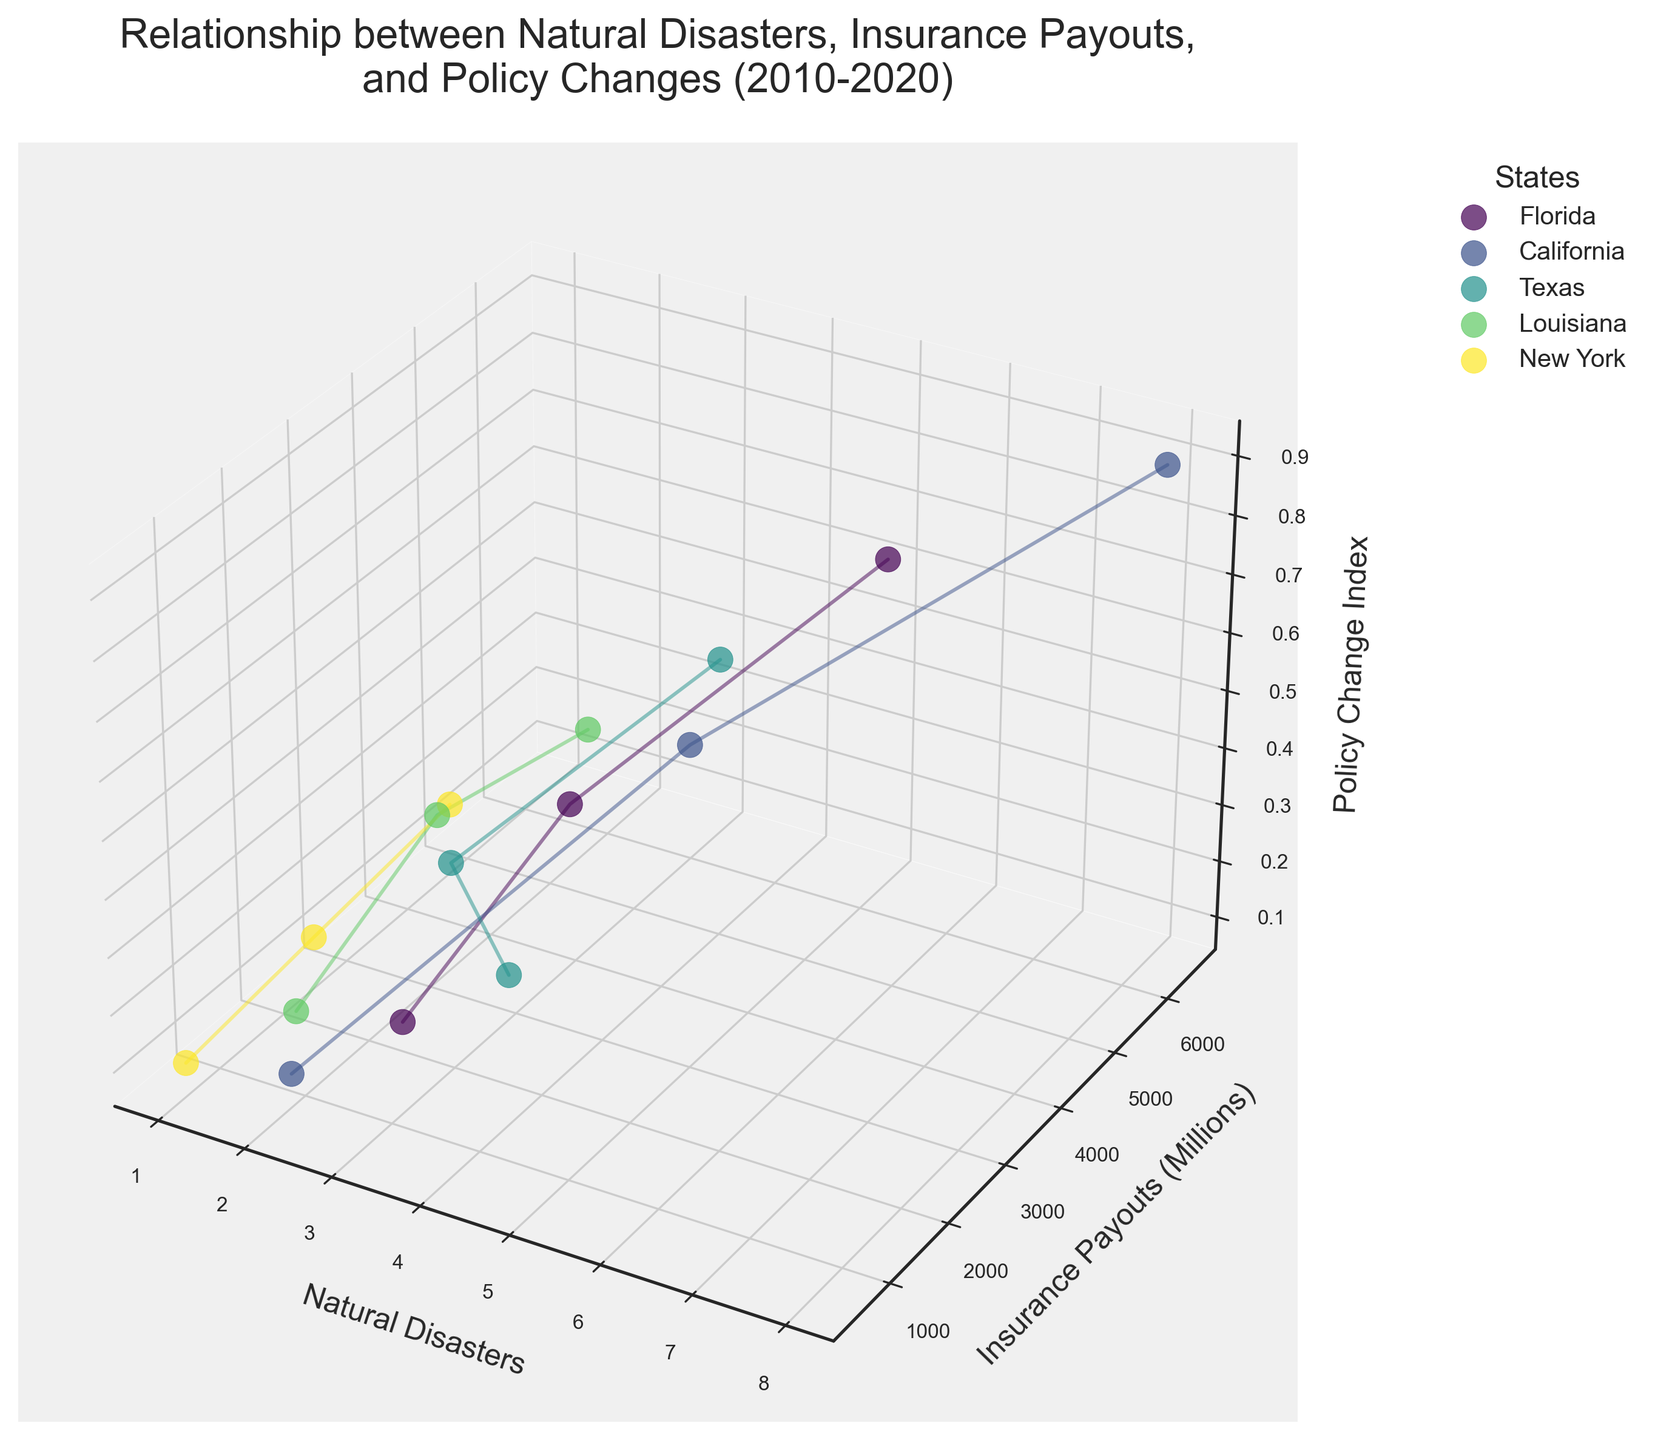What's the title of the figure? The title of the figure is displayed at the top, indicating the main focus of the visualization. It reads "Relationship between Natural Disasters, Insurance Payouts, and Policy Changes (2010-2020)."
Answer: Relationship between Natural Disasters, Insurance Payouts, and Policy Changes (2010-2020) Which state experienced the highest insurance payouts in 2020? By looking at the 3D plot, we find the highest points on the Insurance Payouts (Millions) axis for 2020 and trace them up to their states. California reaches $6500 million, the highest.
Answer: California What is the general trend of insurance payouts over the years for Florida? Track Florida's data points over the years; the payouts rise from 1200 million in 2010 to 2500 million in 2015 and 4800 million in 2020. This indicates a consistent increase.
Answer: Increasing How many natural disasters did Texas experience in 2010? By observing the position of the 2010 data point for Texas on the Natural Disasters axis, we identify the value as 4.
Answer: 4 Which state had the lowest policy change index in 2010? Locate the data points for 2010 on the Policy Change Index axis and compare. New York and California both had the lowest index of 0.1.
Answer: New York and California What is the relationship between the number of natural disasters and insurance payouts for California from 2010 to 2020? Analyzing California's data points, more natural disasters correlate with higher insurance payouts: 2 disasters in 2010 with $800 million, 5 in 2015 with $3000 million, and 8 in 2020 with $6500 million.
Answer: Positive correlation How does the insurance payout in Florida in 2020 compare to that in Texas in the same year? Check the respective data points for Florida and Texas in 2020. Florida's payout is $4800 million, while Texas's is $3500 million. Florida's payout is higher.
Answer: Florida's payout is higher What is the average policy change index for Louisiana across the years? Calculate the average of the policy change index values for Louisiana: (0.2 + 0.5 + 0.6)/3 = 1.3/3 = 0.433.
Answer: 0.433 Which state shows the most significant increase in natural disasters between 2010 and 2020? Compare the number of natural disasters in 2010 and 2020 for all states. California has the largest increase from 2 in 2010 to 8 in 2020, an increase of 6.
Answer: California Describe the trend in natural disasters and insurance payouts for New York from 2010 to 2020. Observe New York's data over the years: natural disasters increase from 1 in 2010 to 3 in 2020, and payouts increase from $500 million to $2000 million, showing an upward trend in both cases.
Answer: Upward trend in both 